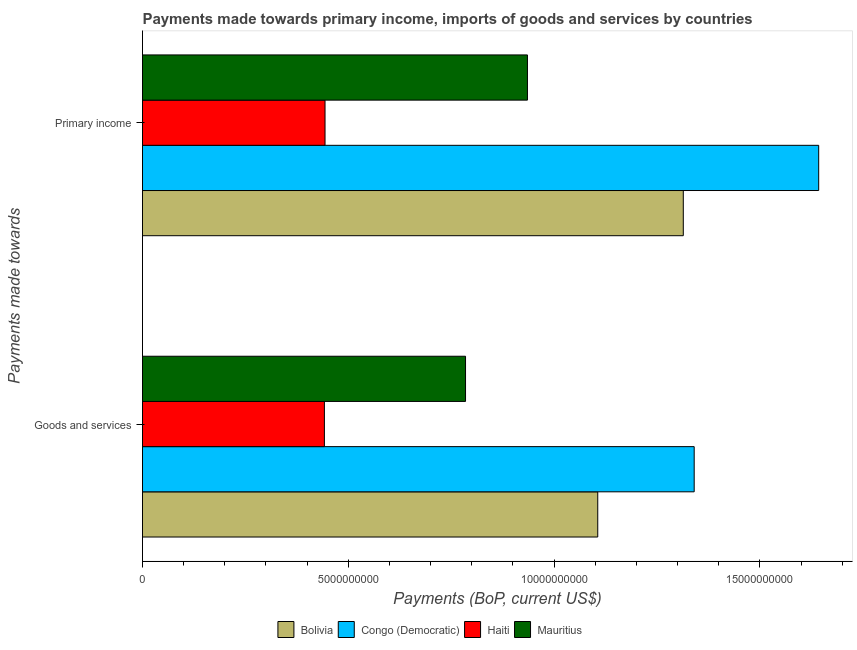How many different coloured bars are there?
Offer a very short reply. 4. Are the number of bars per tick equal to the number of legend labels?
Offer a very short reply. Yes. What is the label of the 1st group of bars from the top?
Provide a short and direct response. Primary income. What is the payments made towards primary income in Bolivia?
Give a very brief answer. 1.31e+1. Across all countries, what is the maximum payments made towards primary income?
Make the answer very short. 1.64e+1. Across all countries, what is the minimum payments made towards goods and services?
Provide a succinct answer. 4.42e+09. In which country was the payments made towards primary income maximum?
Offer a terse response. Congo (Democratic). In which country was the payments made towards goods and services minimum?
Provide a succinct answer. Haiti. What is the total payments made towards goods and services in the graph?
Provide a short and direct response. 3.67e+1. What is the difference between the payments made towards goods and services in Congo (Democratic) and that in Bolivia?
Make the answer very short. 2.34e+09. What is the difference between the payments made towards goods and services in Haiti and the payments made towards primary income in Mauritius?
Provide a succinct answer. -4.93e+09. What is the average payments made towards goods and services per country?
Provide a succinct answer. 9.18e+09. What is the difference between the payments made towards goods and services and payments made towards primary income in Mauritius?
Your answer should be very brief. -1.50e+09. In how many countries, is the payments made towards primary income greater than 7000000000 US$?
Keep it short and to the point. 3. What is the ratio of the payments made towards goods and services in Mauritius to that in Haiti?
Ensure brevity in your answer.  1.78. What does the 3rd bar from the top in Goods and services represents?
Your answer should be compact. Congo (Democratic). What does the 4th bar from the bottom in Goods and services represents?
Make the answer very short. Mauritius. How many bars are there?
Provide a succinct answer. 8. Are all the bars in the graph horizontal?
Provide a succinct answer. Yes. How many countries are there in the graph?
Your answer should be very brief. 4. Does the graph contain grids?
Make the answer very short. No. How many legend labels are there?
Offer a terse response. 4. How are the legend labels stacked?
Ensure brevity in your answer.  Horizontal. What is the title of the graph?
Offer a very short reply. Payments made towards primary income, imports of goods and services by countries. What is the label or title of the X-axis?
Provide a short and direct response. Payments (BoP, current US$). What is the label or title of the Y-axis?
Give a very brief answer. Payments made towards. What is the Payments (BoP, current US$) of Bolivia in Goods and services?
Provide a short and direct response. 1.11e+1. What is the Payments (BoP, current US$) of Congo (Democratic) in Goods and services?
Provide a succinct answer. 1.34e+1. What is the Payments (BoP, current US$) in Haiti in Goods and services?
Keep it short and to the point. 4.42e+09. What is the Payments (BoP, current US$) in Mauritius in Goods and services?
Your response must be concise. 7.85e+09. What is the Payments (BoP, current US$) of Bolivia in Primary income?
Your answer should be compact. 1.31e+1. What is the Payments (BoP, current US$) of Congo (Democratic) in Primary income?
Give a very brief answer. 1.64e+1. What is the Payments (BoP, current US$) of Haiti in Primary income?
Give a very brief answer. 4.43e+09. What is the Payments (BoP, current US$) in Mauritius in Primary income?
Ensure brevity in your answer.  9.35e+09. Across all Payments made towards, what is the maximum Payments (BoP, current US$) of Bolivia?
Provide a succinct answer. 1.31e+1. Across all Payments made towards, what is the maximum Payments (BoP, current US$) in Congo (Democratic)?
Your answer should be very brief. 1.64e+1. Across all Payments made towards, what is the maximum Payments (BoP, current US$) in Haiti?
Offer a terse response. 4.43e+09. Across all Payments made towards, what is the maximum Payments (BoP, current US$) of Mauritius?
Provide a short and direct response. 9.35e+09. Across all Payments made towards, what is the minimum Payments (BoP, current US$) of Bolivia?
Make the answer very short. 1.11e+1. Across all Payments made towards, what is the minimum Payments (BoP, current US$) in Congo (Democratic)?
Ensure brevity in your answer.  1.34e+1. Across all Payments made towards, what is the minimum Payments (BoP, current US$) of Haiti?
Provide a short and direct response. 4.42e+09. Across all Payments made towards, what is the minimum Payments (BoP, current US$) of Mauritius?
Offer a terse response. 7.85e+09. What is the total Payments (BoP, current US$) in Bolivia in the graph?
Your response must be concise. 2.42e+1. What is the total Payments (BoP, current US$) in Congo (Democratic) in the graph?
Provide a short and direct response. 2.98e+1. What is the total Payments (BoP, current US$) in Haiti in the graph?
Your response must be concise. 8.85e+09. What is the total Payments (BoP, current US$) in Mauritius in the graph?
Offer a very short reply. 1.72e+1. What is the difference between the Payments (BoP, current US$) of Bolivia in Goods and services and that in Primary income?
Make the answer very short. -2.08e+09. What is the difference between the Payments (BoP, current US$) of Congo (Democratic) in Goods and services and that in Primary income?
Provide a short and direct response. -3.02e+09. What is the difference between the Payments (BoP, current US$) of Haiti in Goods and services and that in Primary income?
Give a very brief answer. -1.50e+07. What is the difference between the Payments (BoP, current US$) in Mauritius in Goods and services and that in Primary income?
Provide a succinct answer. -1.50e+09. What is the difference between the Payments (BoP, current US$) in Bolivia in Goods and services and the Payments (BoP, current US$) in Congo (Democratic) in Primary income?
Your answer should be very brief. -5.37e+09. What is the difference between the Payments (BoP, current US$) in Bolivia in Goods and services and the Payments (BoP, current US$) in Haiti in Primary income?
Provide a succinct answer. 6.63e+09. What is the difference between the Payments (BoP, current US$) of Bolivia in Goods and services and the Payments (BoP, current US$) of Mauritius in Primary income?
Give a very brief answer. 1.71e+09. What is the difference between the Payments (BoP, current US$) in Congo (Democratic) in Goods and services and the Payments (BoP, current US$) in Haiti in Primary income?
Offer a terse response. 8.97e+09. What is the difference between the Payments (BoP, current US$) of Congo (Democratic) in Goods and services and the Payments (BoP, current US$) of Mauritius in Primary income?
Your answer should be very brief. 4.05e+09. What is the difference between the Payments (BoP, current US$) in Haiti in Goods and services and the Payments (BoP, current US$) in Mauritius in Primary income?
Provide a short and direct response. -4.93e+09. What is the average Payments (BoP, current US$) in Bolivia per Payments made towards?
Your answer should be compact. 1.21e+1. What is the average Payments (BoP, current US$) in Congo (Democratic) per Payments made towards?
Your answer should be compact. 1.49e+1. What is the average Payments (BoP, current US$) of Haiti per Payments made towards?
Your answer should be compact. 4.43e+09. What is the average Payments (BoP, current US$) of Mauritius per Payments made towards?
Offer a very short reply. 8.60e+09. What is the difference between the Payments (BoP, current US$) in Bolivia and Payments (BoP, current US$) in Congo (Democratic) in Goods and services?
Provide a succinct answer. -2.34e+09. What is the difference between the Payments (BoP, current US$) in Bolivia and Payments (BoP, current US$) in Haiti in Goods and services?
Provide a short and direct response. 6.64e+09. What is the difference between the Payments (BoP, current US$) of Bolivia and Payments (BoP, current US$) of Mauritius in Goods and services?
Offer a very short reply. 3.21e+09. What is the difference between the Payments (BoP, current US$) of Congo (Democratic) and Payments (BoP, current US$) of Haiti in Goods and services?
Keep it short and to the point. 8.98e+09. What is the difference between the Payments (BoP, current US$) of Congo (Democratic) and Payments (BoP, current US$) of Mauritius in Goods and services?
Provide a succinct answer. 5.56e+09. What is the difference between the Payments (BoP, current US$) of Haiti and Payments (BoP, current US$) of Mauritius in Goods and services?
Keep it short and to the point. -3.43e+09. What is the difference between the Payments (BoP, current US$) in Bolivia and Payments (BoP, current US$) in Congo (Democratic) in Primary income?
Your response must be concise. -3.29e+09. What is the difference between the Payments (BoP, current US$) of Bolivia and Payments (BoP, current US$) of Haiti in Primary income?
Your answer should be very brief. 8.70e+09. What is the difference between the Payments (BoP, current US$) of Bolivia and Payments (BoP, current US$) of Mauritius in Primary income?
Your response must be concise. 3.79e+09. What is the difference between the Payments (BoP, current US$) in Congo (Democratic) and Payments (BoP, current US$) in Haiti in Primary income?
Offer a terse response. 1.20e+1. What is the difference between the Payments (BoP, current US$) in Congo (Democratic) and Payments (BoP, current US$) in Mauritius in Primary income?
Keep it short and to the point. 7.08e+09. What is the difference between the Payments (BoP, current US$) in Haiti and Payments (BoP, current US$) in Mauritius in Primary income?
Ensure brevity in your answer.  -4.92e+09. What is the ratio of the Payments (BoP, current US$) of Bolivia in Goods and services to that in Primary income?
Offer a terse response. 0.84. What is the ratio of the Payments (BoP, current US$) of Congo (Democratic) in Goods and services to that in Primary income?
Offer a terse response. 0.82. What is the ratio of the Payments (BoP, current US$) in Mauritius in Goods and services to that in Primary income?
Keep it short and to the point. 0.84. What is the difference between the highest and the second highest Payments (BoP, current US$) in Bolivia?
Offer a very short reply. 2.08e+09. What is the difference between the highest and the second highest Payments (BoP, current US$) in Congo (Democratic)?
Offer a very short reply. 3.02e+09. What is the difference between the highest and the second highest Payments (BoP, current US$) in Haiti?
Your response must be concise. 1.50e+07. What is the difference between the highest and the second highest Payments (BoP, current US$) in Mauritius?
Your answer should be compact. 1.50e+09. What is the difference between the highest and the lowest Payments (BoP, current US$) in Bolivia?
Provide a short and direct response. 2.08e+09. What is the difference between the highest and the lowest Payments (BoP, current US$) of Congo (Democratic)?
Ensure brevity in your answer.  3.02e+09. What is the difference between the highest and the lowest Payments (BoP, current US$) of Haiti?
Give a very brief answer. 1.50e+07. What is the difference between the highest and the lowest Payments (BoP, current US$) in Mauritius?
Make the answer very short. 1.50e+09. 